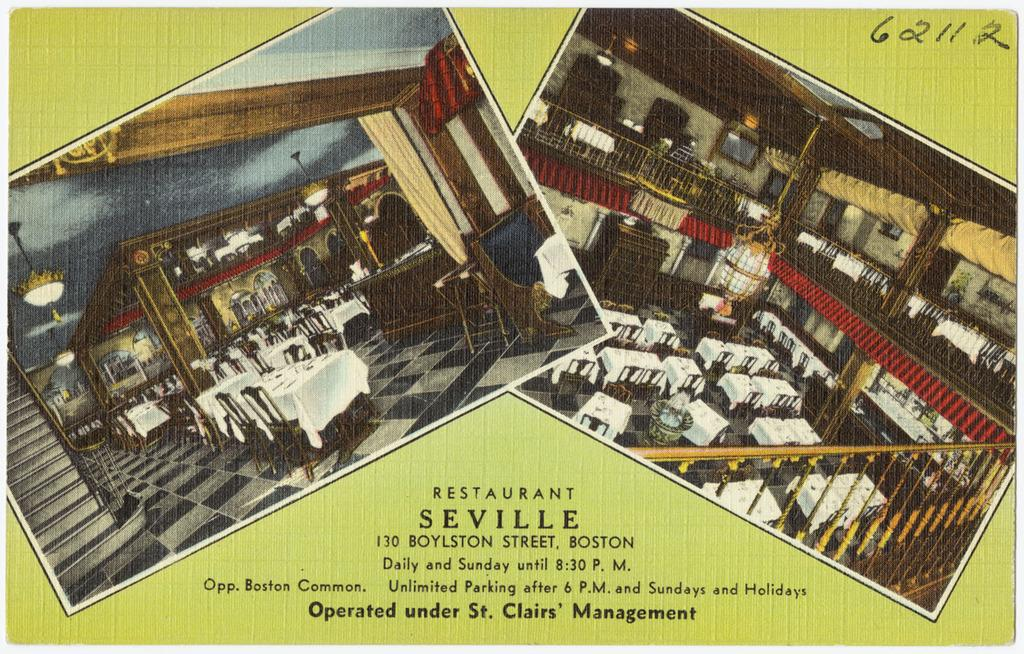Provide a one-sentence caption for the provided image. An ad for the Restaurant Seville states it is run by St. Clairs' Management. 